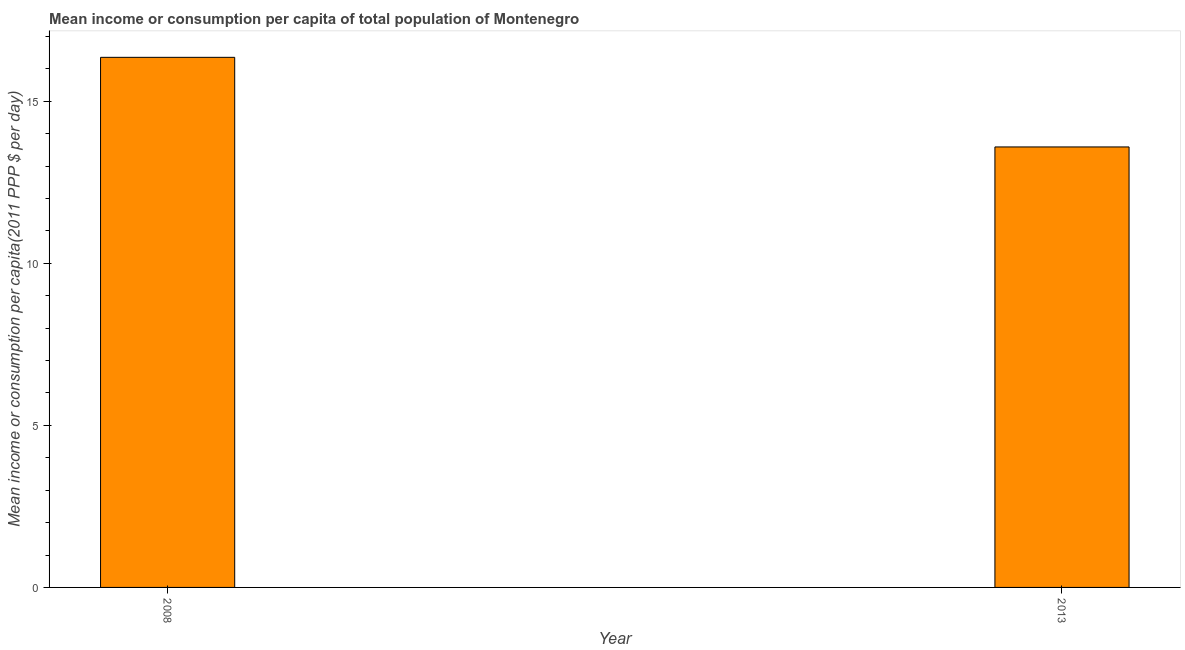Does the graph contain any zero values?
Keep it short and to the point. No. Does the graph contain grids?
Ensure brevity in your answer.  No. What is the title of the graph?
Make the answer very short. Mean income or consumption per capita of total population of Montenegro. What is the label or title of the X-axis?
Provide a succinct answer. Year. What is the label or title of the Y-axis?
Provide a short and direct response. Mean income or consumption per capita(2011 PPP $ per day). What is the mean income or consumption in 2008?
Ensure brevity in your answer.  16.35. Across all years, what is the maximum mean income or consumption?
Your answer should be compact. 16.35. Across all years, what is the minimum mean income or consumption?
Your answer should be compact. 13.59. In which year was the mean income or consumption maximum?
Offer a very short reply. 2008. In which year was the mean income or consumption minimum?
Ensure brevity in your answer.  2013. What is the sum of the mean income or consumption?
Give a very brief answer. 29.94. What is the difference between the mean income or consumption in 2008 and 2013?
Your answer should be compact. 2.77. What is the average mean income or consumption per year?
Provide a short and direct response. 14.97. What is the median mean income or consumption?
Give a very brief answer. 14.97. Do a majority of the years between 2008 and 2013 (inclusive) have mean income or consumption greater than 13 $?
Ensure brevity in your answer.  Yes. What is the ratio of the mean income or consumption in 2008 to that in 2013?
Offer a very short reply. 1.2. In how many years, is the mean income or consumption greater than the average mean income or consumption taken over all years?
Ensure brevity in your answer.  1. Are all the bars in the graph horizontal?
Ensure brevity in your answer.  No. How many years are there in the graph?
Keep it short and to the point. 2. What is the difference between two consecutive major ticks on the Y-axis?
Ensure brevity in your answer.  5. What is the Mean income or consumption per capita(2011 PPP $ per day) of 2008?
Offer a very short reply. 16.35. What is the Mean income or consumption per capita(2011 PPP $ per day) in 2013?
Your answer should be compact. 13.59. What is the difference between the Mean income or consumption per capita(2011 PPP $ per day) in 2008 and 2013?
Keep it short and to the point. 2.76. What is the ratio of the Mean income or consumption per capita(2011 PPP $ per day) in 2008 to that in 2013?
Provide a short and direct response. 1.2. 